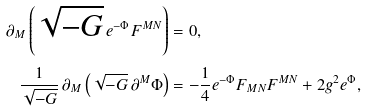<formula> <loc_0><loc_0><loc_500><loc_500>\partial _ { M } \left ( \sqrt { - G } \, e ^ { - \Phi } F ^ { M N } \right ) & = 0 , \\ \frac { 1 } { \sqrt { - G } } \, \partial _ { M } \left ( \sqrt { - G } \, \partial ^ { M } \Phi \right ) & = - \frac { 1 } { 4 } e ^ { - \Phi } F _ { M N } F ^ { M N } + 2 g ^ { 2 } e ^ { \Phi } ,</formula> 